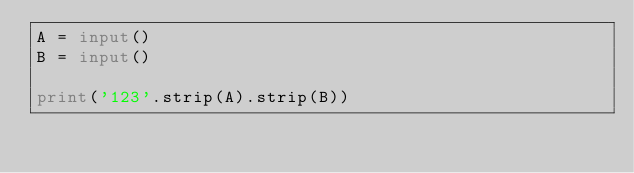Convert code to text. <code><loc_0><loc_0><loc_500><loc_500><_Python_>A = input()
B = input()

print('123'.strip(A).strip(B))</code> 